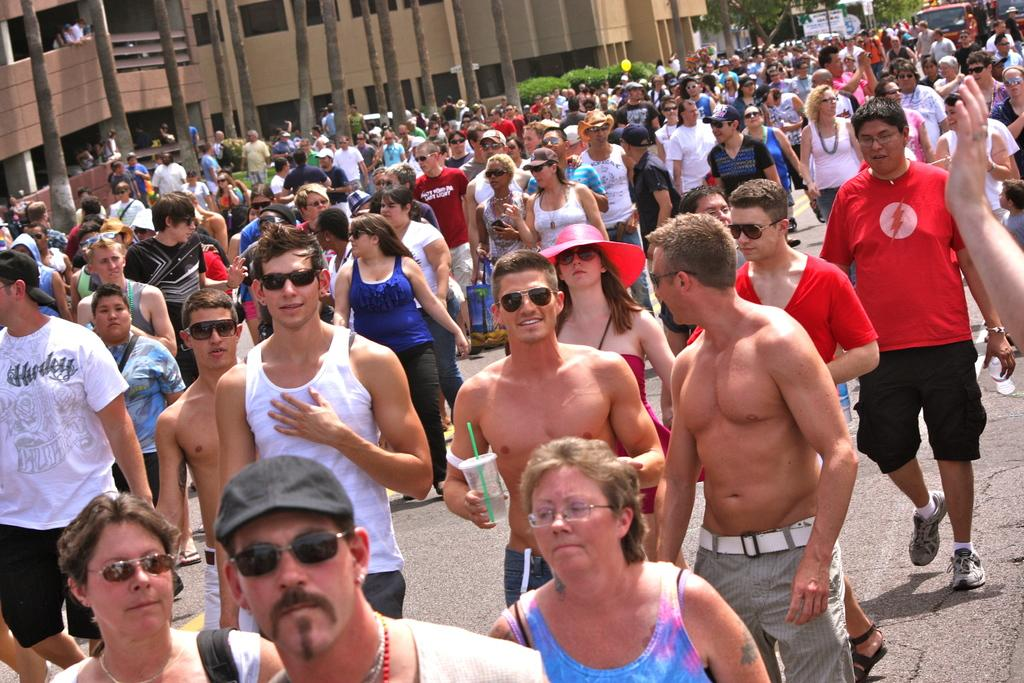What are the people in the image doing? There is a group of persons standing on the road in the image. What can be seen in the background of the image? There are trees visible in the image. What is moving on the road in the image? There is a truck traveling on the road in the image. What type of structures are present in the image? There are buildings in the image. Can you see a match being lit by a grandmother in the image? There is no match or grandmother present in the image. 